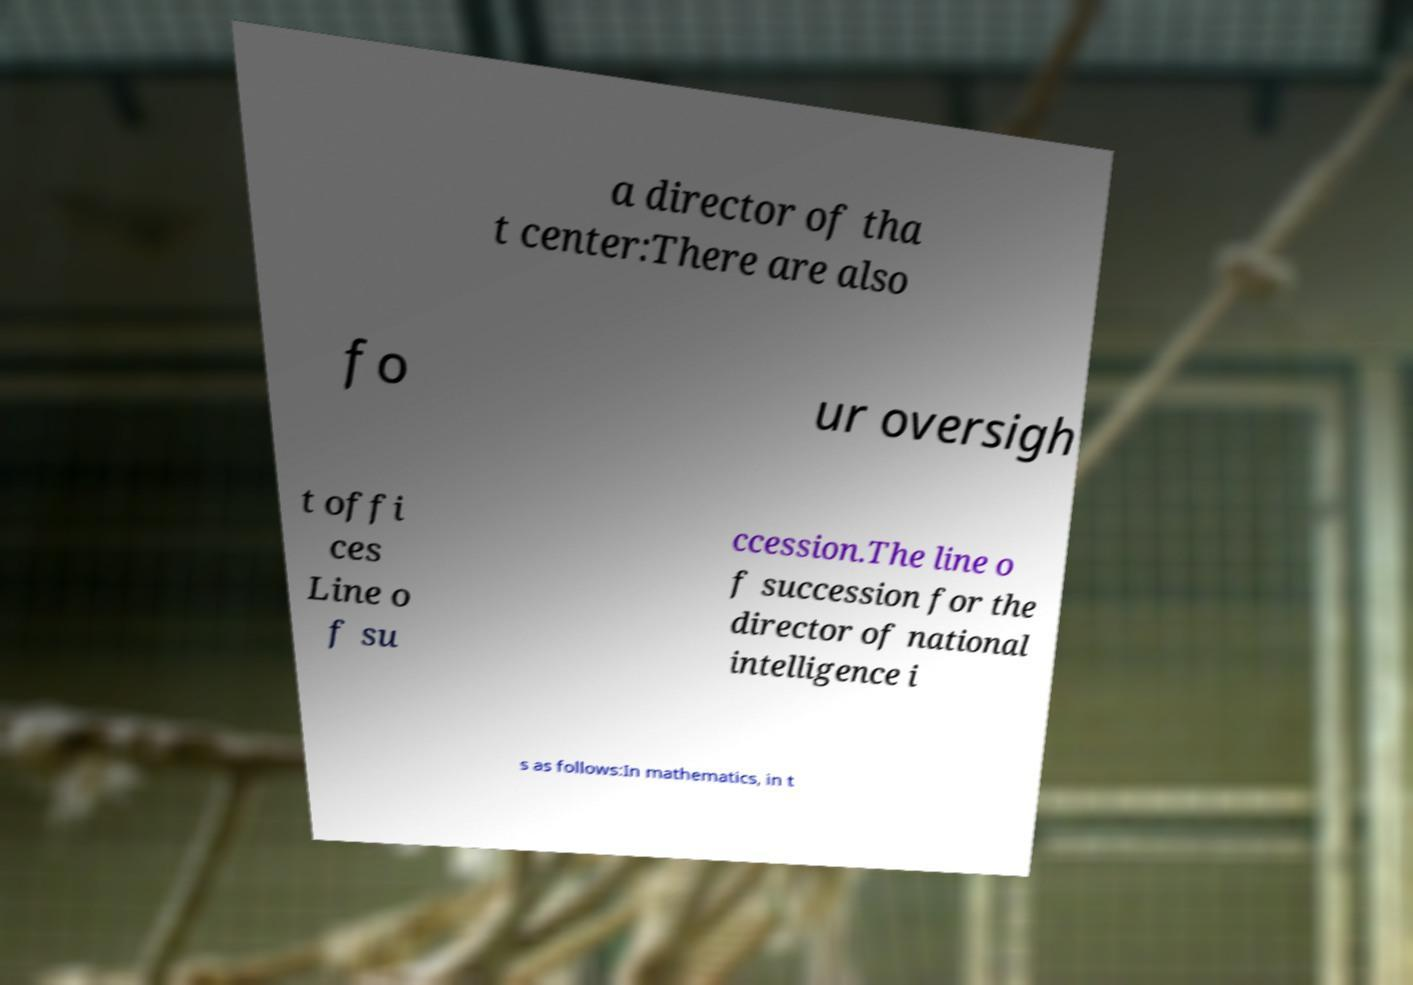Please identify and transcribe the text found in this image. a director of tha t center:There are also fo ur oversigh t offi ces Line o f su ccession.The line o f succession for the director of national intelligence i s as follows:In mathematics, in t 